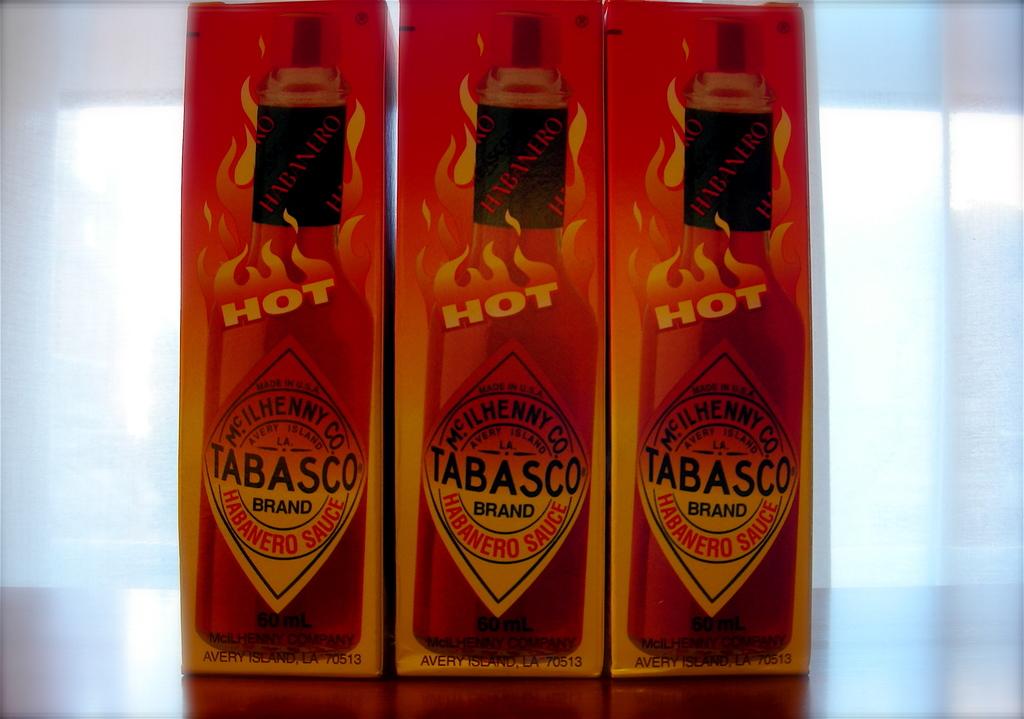What is the name of the hot sauce?
Give a very brief answer. Tabasco. What word is on fire?
Make the answer very short. Hot. 